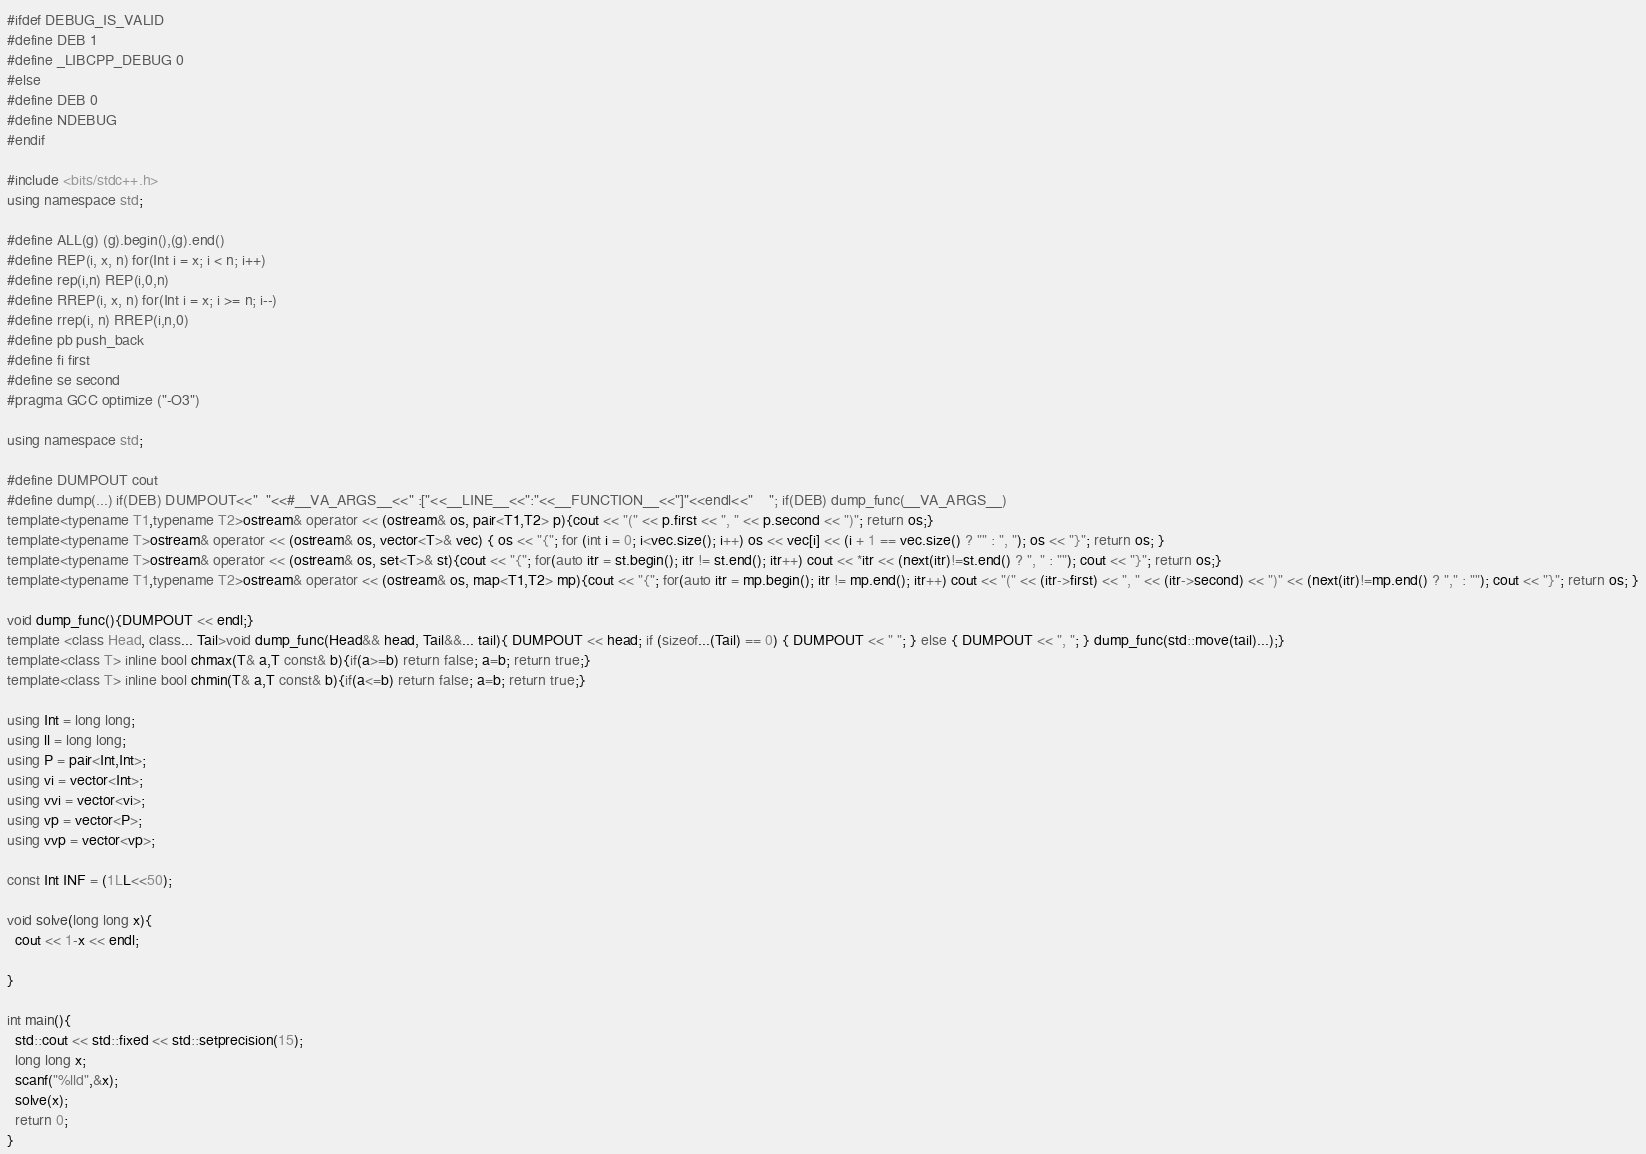<code> <loc_0><loc_0><loc_500><loc_500><_C++_>#ifdef DEBUG_IS_VALID
#define DEB 1 
#define _LIBCPP_DEBUG 0
#else
#define DEB 0
#define NDEBUG
#endif

#include <bits/stdc++.h>
using namespace std;

#define ALL(g) (g).begin(),(g).end()
#define REP(i, x, n) for(Int i = x; i < n; i++)
#define rep(i,n) REP(i,0,n)
#define RREP(i, x, n) for(Int i = x; i >= n; i--)
#define rrep(i, n) RREP(i,n,0)
#define pb push_back
#define fi first
#define se second
#pragma GCC optimize ("-O3")

using namespace std;

#define DUMPOUT cout
#define dump(...) if(DEB) DUMPOUT<<"  "<<#__VA_ARGS__<<" :["<<__LINE__<<":"<<__FUNCTION__<<"]"<<endl<<"    "; if(DEB) dump_func(__VA_ARGS__)
template<typename T1,typename T2>ostream& operator << (ostream& os, pair<T1,T2> p){cout << "(" << p.first << ", " << p.second << ")"; return os;}
template<typename T>ostream& operator << (ostream& os, vector<T>& vec) { os << "{"; for (int i = 0; i<vec.size(); i++) os << vec[i] << (i + 1 == vec.size() ? "" : ", "); os << "}"; return os; }
template<typename T>ostream& operator << (ostream& os, set<T>& st){cout << "{"; for(auto itr = st.begin(); itr != st.end(); itr++) cout << *itr << (next(itr)!=st.end() ? ", " : ""); cout << "}"; return os;}
template<typename T1,typename T2>ostream& operator << (ostream& os, map<T1,T2> mp){cout << "{"; for(auto itr = mp.begin(); itr != mp.end(); itr++) cout << "(" << (itr->first) << ", " << (itr->second) << ")" << (next(itr)!=mp.end() ? "," : ""); cout << "}"; return os; }

void dump_func(){DUMPOUT << endl;}
template <class Head, class... Tail>void dump_func(Head&& head, Tail&&... tail){ DUMPOUT << head; if (sizeof...(Tail) == 0) { DUMPOUT << " "; } else { DUMPOUT << ", "; } dump_func(std::move(tail)...);}
template<class T> inline bool chmax(T& a,T const& b){if(a>=b) return false; a=b; return true;}
template<class T> inline bool chmin(T& a,T const& b){if(a<=b) return false; a=b; return true;}

using Int = long long;
using ll = long long;
using P = pair<Int,Int>;
using vi = vector<Int>;
using vvi = vector<vi>;
using vp = vector<P>;
using vvp = vector<vp>;

const Int INF = (1LL<<50);

void solve(long long x){
  cout << 1-x << endl;

}

int main(){
  std::cout << std::fixed << std::setprecision(15);
  long long x;
  scanf("%lld",&x);
  solve(x);
  return 0;
}
</code> 